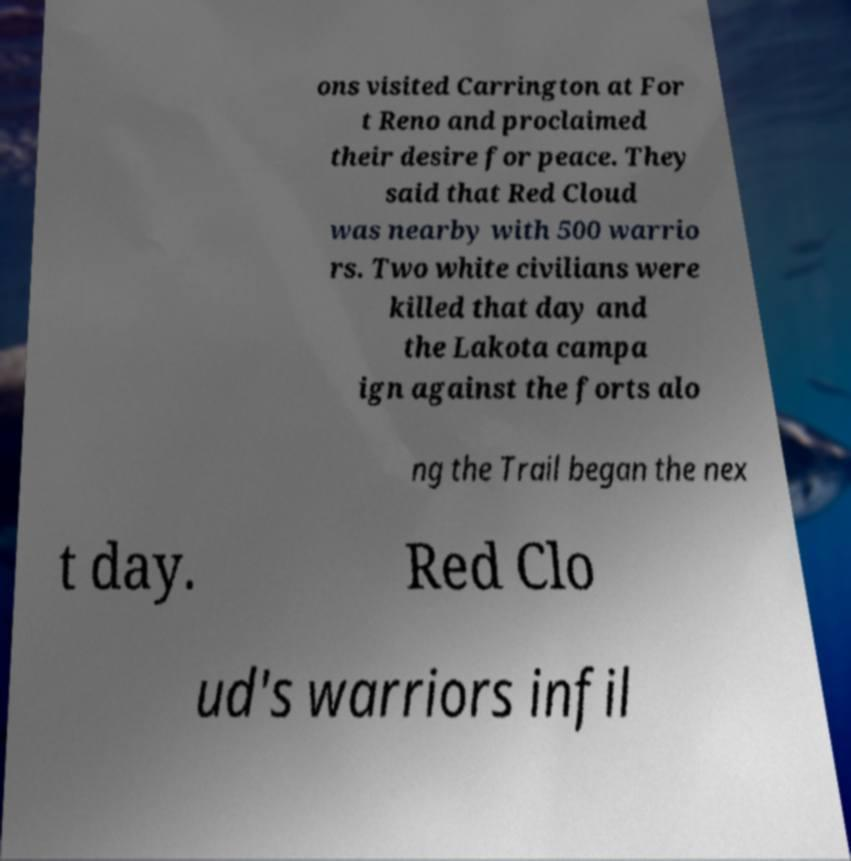Could you extract and type out the text from this image? ons visited Carrington at For t Reno and proclaimed their desire for peace. They said that Red Cloud was nearby with 500 warrio rs. Two white civilians were killed that day and the Lakota campa ign against the forts alo ng the Trail began the nex t day. Red Clo ud's warriors infil 